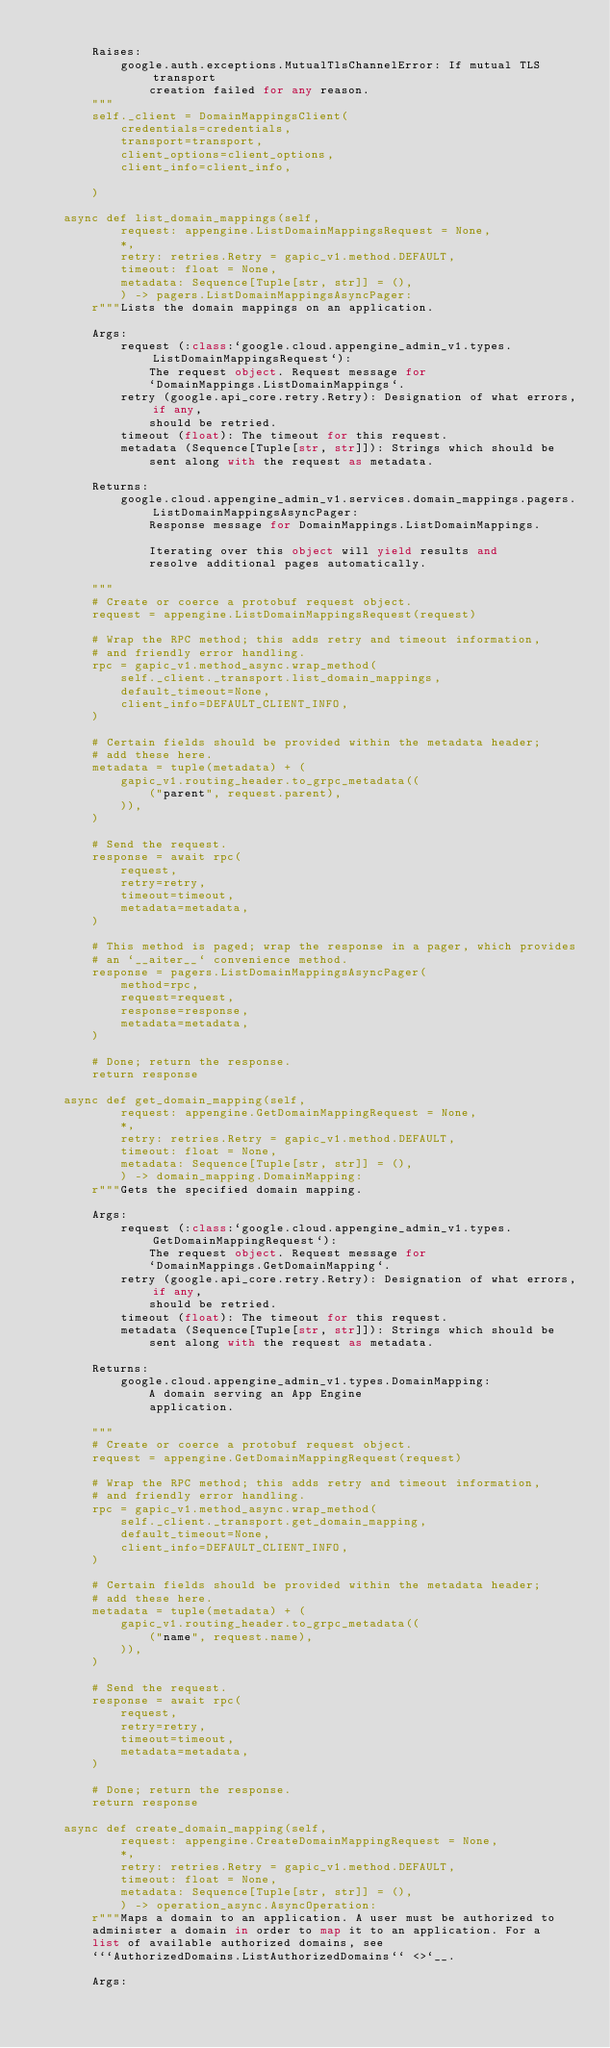Convert code to text. <code><loc_0><loc_0><loc_500><loc_500><_Python_>
        Raises:
            google.auth.exceptions.MutualTlsChannelError: If mutual TLS transport
                creation failed for any reason.
        """
        self._client = DomainMappingsClient(
            credentials=credentials,
            transport=transport,
            client_options=client_options,
            client_info=client_info,

        )

    async def list_domain_mappings(self,
            request: appengine.ListDomainMappingsRequest = None,
            *,
            retry: retries.Retry = gapic_v1.method.DEFAULT,
            timeout: float = None,
            metadata: Sequence[Tuple[str, str]] = (),
            ) -> pagers.ListDomainMappingsAsyncPager:
        r"""Lists the domain mappings on an application.

        Args:
            request (:class:`google.cloud.appengine_admin_v1.types.ListDomainMappingsRequest`):
                The request object. Request message for
                `DomainMappings.ListDomainMappings`.
            retry (google.api_core.retry.Retry): Designation of what errors, if any,
                should be retried.
            timeout (float): The timeout for this request.
            metadata (Sequence[Tuple[str, str]]): Strings which should be
                sent along with the request as metadata.

        Returns:
            google.cloud.appengine_admin_v1.services.domain_mappings.pagers.ListDomainMappingsAsyncPager:
                Response message for DomainMappings.ListDomainMappings.

                Iterating over this object will yield results and
                resolve additional pages automatically.

        """
        # Create or coerce a protobuf request object.
        request = appengine.ListDomainMappingsRequest(request)

        # Wrap the RPC method; this adds retry and timeout information,
        # and friendly error handling.
        rpc = gapic_v1.method_async.wrap_method(
            self._client._transport.list_domain_mappings,
            default_timeout=None,
            client_info=DEFAULT_CLIENT_INFO,
        )

        # Certain fields should be provided within the metadata header;
        # add these here.
        metadata = tuple(metadata) + (
            gapic_v1.routing_header.to_grpc_metadata((
                ("parent", request.parent),
            )),
        )

        # Send the request.
        response = await rpc(
            request,
            retry=retry,
            timeout=timeout,
            metadata=metadata,
        )

        # This method is paged; wrap the response in a pager, which provides
        # an `__aiter__` convenience method.
        response = pagers.ListDomainMappingsAsyncPager(
            method=rpc,
            request=request,
            response=response,
            metadata=metadata,
        )

        # Done; return the response.
        return response

    async def get_domain_mapping(self,
            request: appengine.GetDomainMappingRequest = None,
            *,
            retry: retries.Retry = gapic_v1.method.DEFAULT,
            timeout: float = None,
            metadata: Sequence[Tuple[str, str]] = (),
            ) -> domain_mapping.DomainMapping:
        r"""Gets the specified domain mapping.

        Args:
            request (:class:`google.cloud.appengine_admin_v1.types.GetDomainMappingRequest`):
                The request object. Request message for
                `DomainMappings.GetDomainMapping`.
            retry (google.api_core.retry.Retry): Designation of what errors, if any,
                should be retried.
            timeout (float): The timeout for this request.
            metadata (Sequence[Tuple[str, str]]): Strings which should be
                sent along with the request as metadata.

        Returns:
            google.cloud.appengine_admin_v1.types.DomainMapping:
                A domain serving an App Engine
                application.

        """
        # Create or coerce a protobuf request object.
        request = appengine.GetDomainMappingRequest(request)

        # Wrap the RPC method; this adds retry and timeout information,
        # and friendly error handling.
        rpc = gapic_v1.method_async.wrap_method(
            self._client._transport.get_domain_mapping,
            default_timeout=None,
            client_info=DEFAULT_CLIENT_INFO,
        )

        # Certain fields should be provided within the metadata header;
        # add these here.
        metadata = tuple(metadata) + (
            gapic_v1.routing_header.to_grpc_metadata((
                ("name", request.name),
            )),
        )

        # Send the request.
        response = await rpc(
            request,
            retry=retry,
            timeout=timeout,
            metadata=metadata,
        )

        # Done; return the response.
        return response

    async def create_domain_mapping(self,
            request: appengine.CreateDomainMappingRequest = None,
            *,
            retry: retries.Retry = gapic_v1.method.DEFAULT,
            timeout: float = None,
            metadata: Sequence[Tuple[str, str]] = (),
            ) -> operation_async.AsyncOperation:
        r"""Maps a domain to an application. A user must be authorized to
        administer a domain in order to map it to an application. For a
        list of available authorized domains, see
        ```AuthorizedDomains.ListAuthorizedDomains`` <>`__.

        Args:</code> 